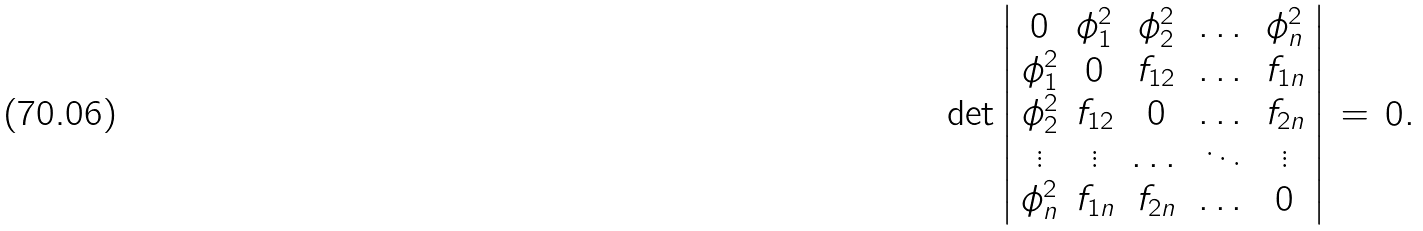<formula> <loc_0><loc_0><loc_500><loc_500>\det \left | \begin{array} { c c c c c } 0 & \phi _ { 1 } ^ { 2 } & \phi _ { 2 } ^ { 2 } & \dots & \phi _ { n } ^ { 2 } \\ \phi _ { 1 } ^ { 2 } & 0 & f _ { 1 2 } & \dots & f _ { 1 n } \\ \phi _ { 2 } ^ { 2 } & f _ { 1 2 } & 0 & \dots & f _ { 2 n } \\ \vdots & \vdots & \dots & \ddots & \vdots \\ \phi _ { n } ^ { 2 } & f _ { 1 n } & f _ { 2 n } & \dots & 0 \end{array} \right | \, = \, 0 .</formula> 